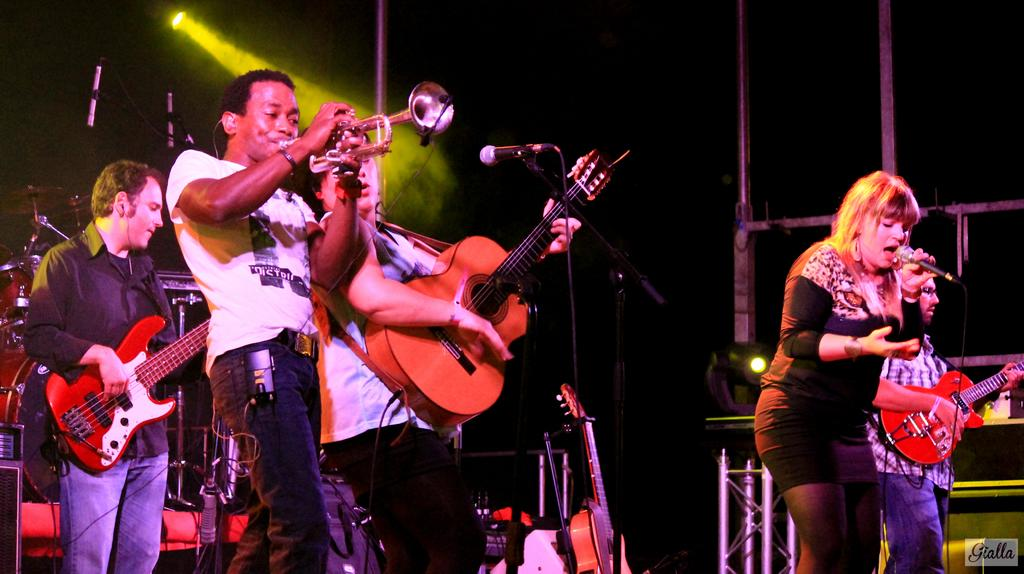How many people are on stage in the image? There are four people on stage in the image. What are the people on stage doing? The people on stage are playing musical instruments. What types of musical instruments can be seen in the image? There are musical instruments and guitars visible behind the people on stage. Can you describe the lighting in the image? There is a yellow light in the image. What type of thread is being used to hold the people on stage together? There is no thread visible in the image, and the people on stage are not being held together by any visible means. 